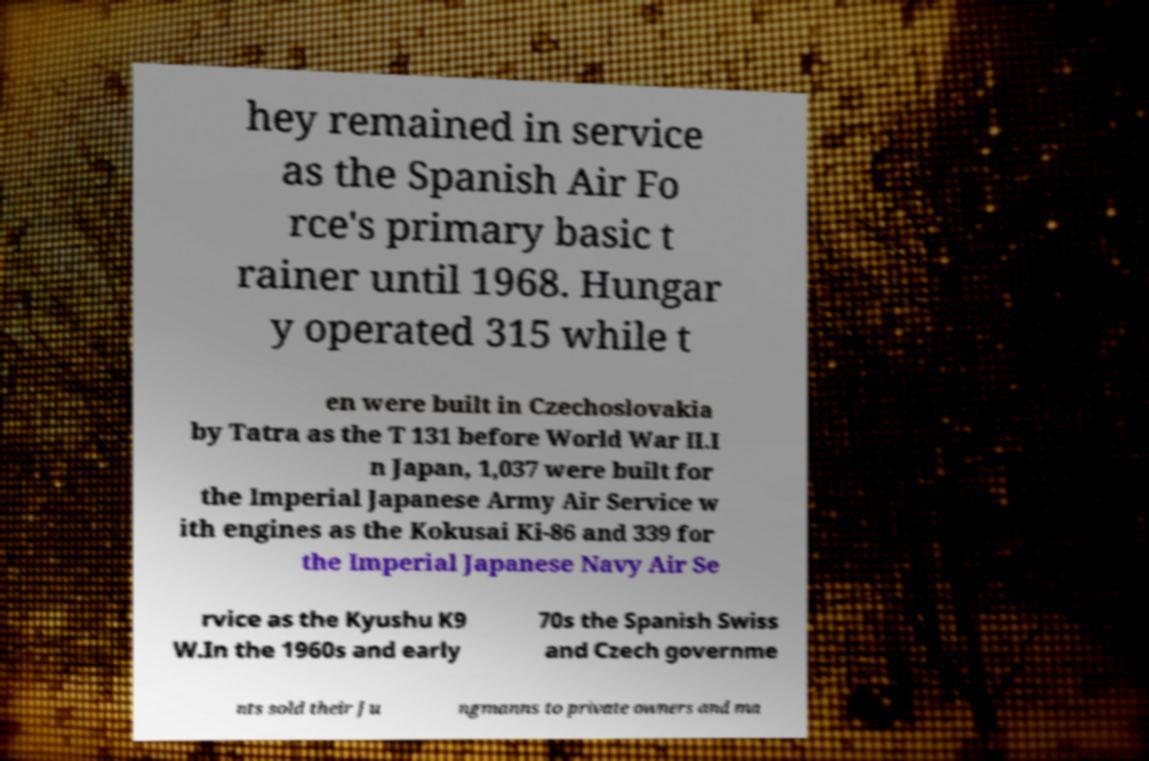I need the written content from this picture converted into text. Can you do that? hey remained in service as the Spanish Air Fo rce's primary basic t rainer until 1968. Hungar y operated 315 while t en were built in Czechoslovakia by Tatra as the T 131 before World War II.I n Japan, 1,037 were built for the Imperial Japanese Army Air Service w ith engines as the Kokusai Ki-86 and 339 for the Imperial Japanese Navy Air Se rvice as the Kyushu K9 W.In the 1960s and early 70s the Spanish Swiss and Czech governme nts sold their Ju ngmanns to private owners and ma 